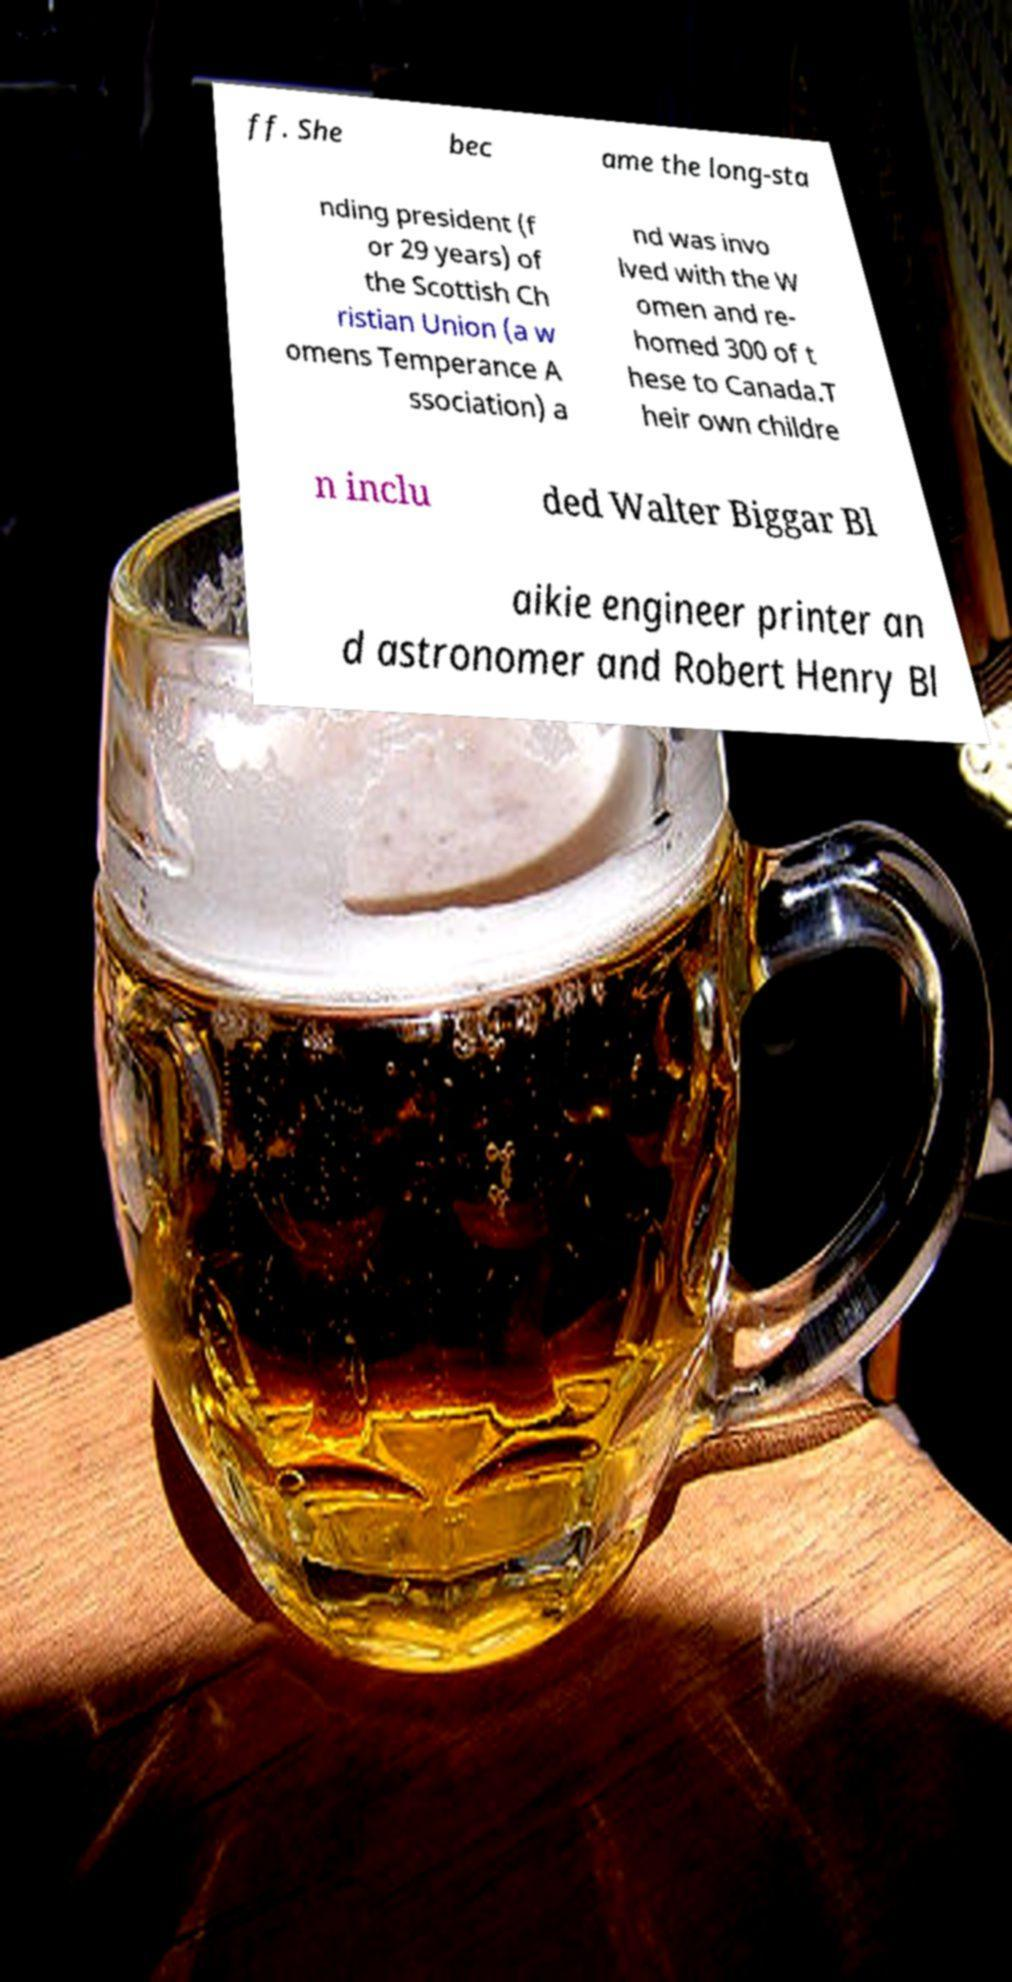Please identify and transcribe the text found in this image. ff. She bec ame the long-sta nding president (f or 29 years) of the Scottish Ch ristian Union (a w omens Temperance A ssociation) a nd was invo lved with the W omen and re- homed 300 of t hese to Canada.T heir own childre n inclu ded Walter Biggar Bl aikie engineer printer an d astronomer and Robert Henry Bl 